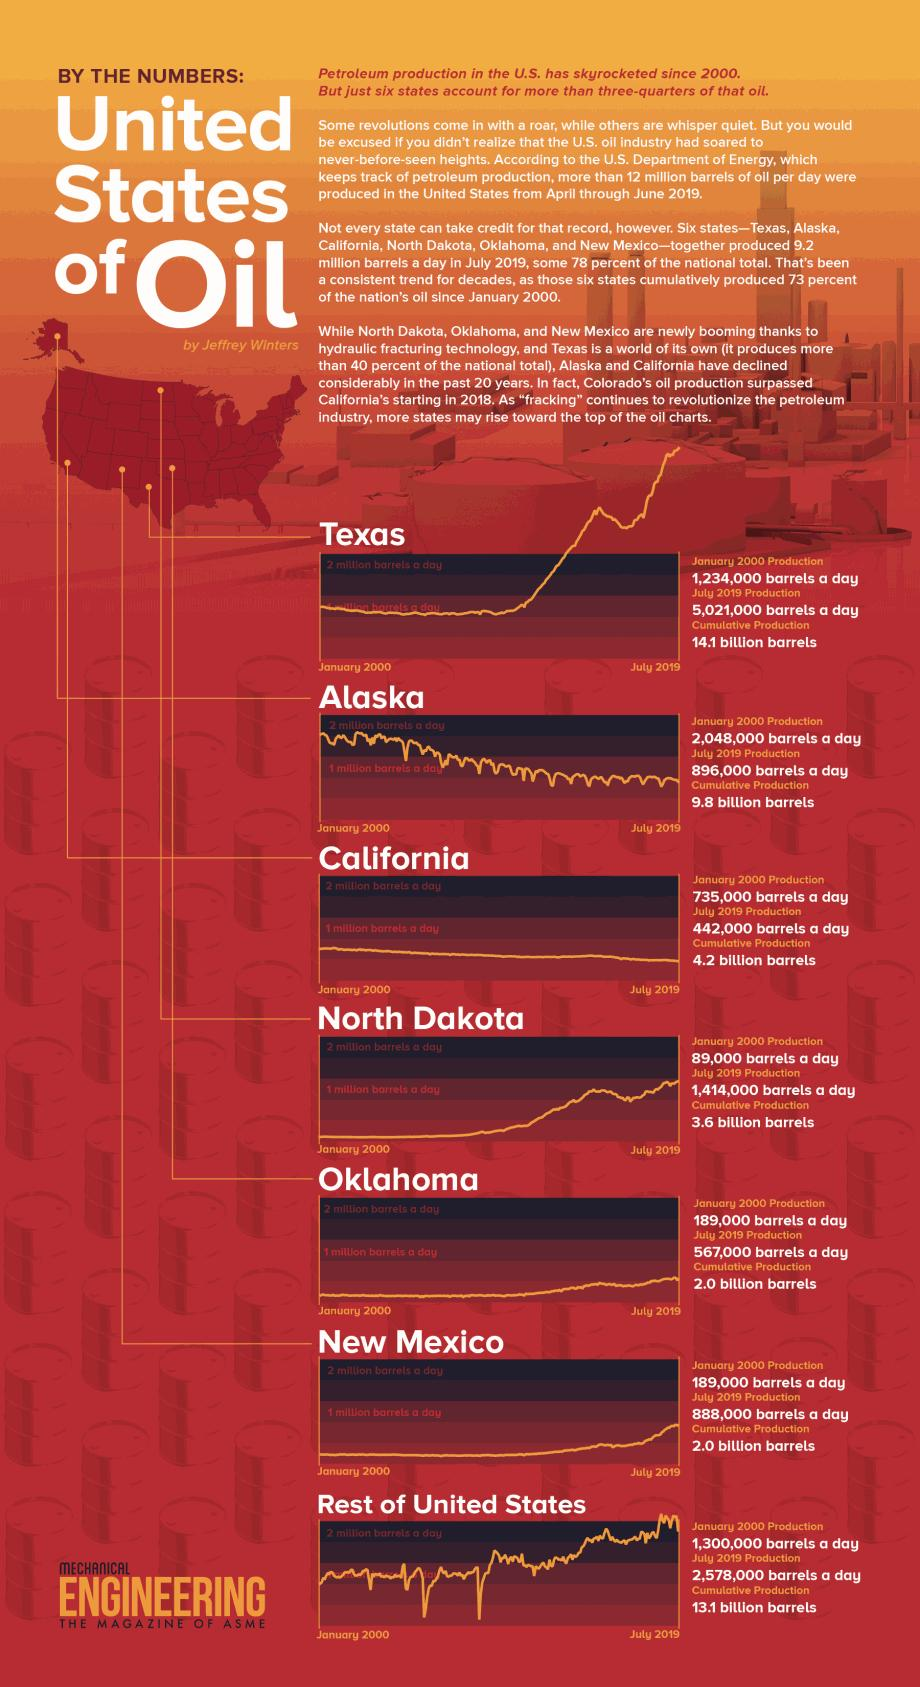Give some essential details in this illustration. As of 2019, the cumulative production of Texas is estimated to be approximately 14.1 billion barrels. In January, the production of oil in Oklahoma was 189,000 barrels per day. After the rest of the United States, Alaska had the next highest cumulative production. The source of the information is THE MAGAZINE OF ASME. 